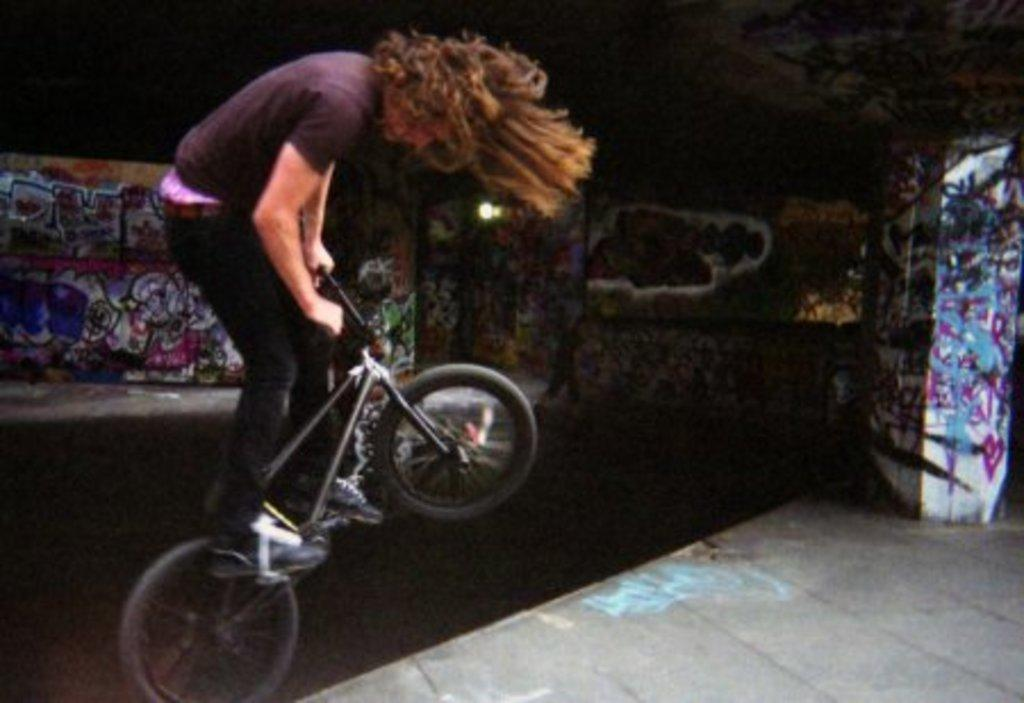What is the main activity being performed in the image? There is a person cycling in the image. On which side of the image is the person cycling? The person is on the left side of the image. What can be seen in the background of the image? There are posters in the background of the image. What type of heart can be seen beating in the image? There is no heart visible in the image; it features a person cycling and posters in the background. 